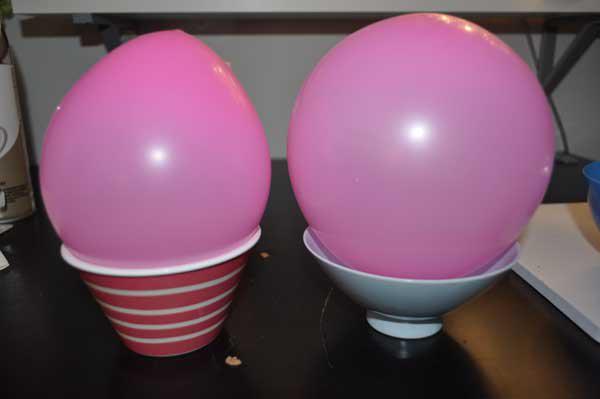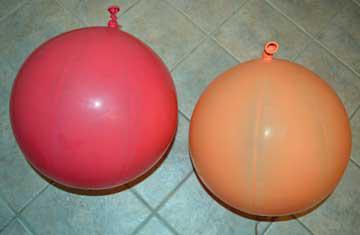The first image is the image on the left, the second image is the image on the right. Evaluate the accuracy of this statement regarding the images: "The left image contains at least two red balloons.". Is it true? Answer yes or no. No. The first image is the image on the left, the second image is the image on the right. Assess this claim about the two images: "An image shows exactly two balloons of different colors, posed horizontally side-by-side.". Correct or not? Answer yes or no. Yes. 